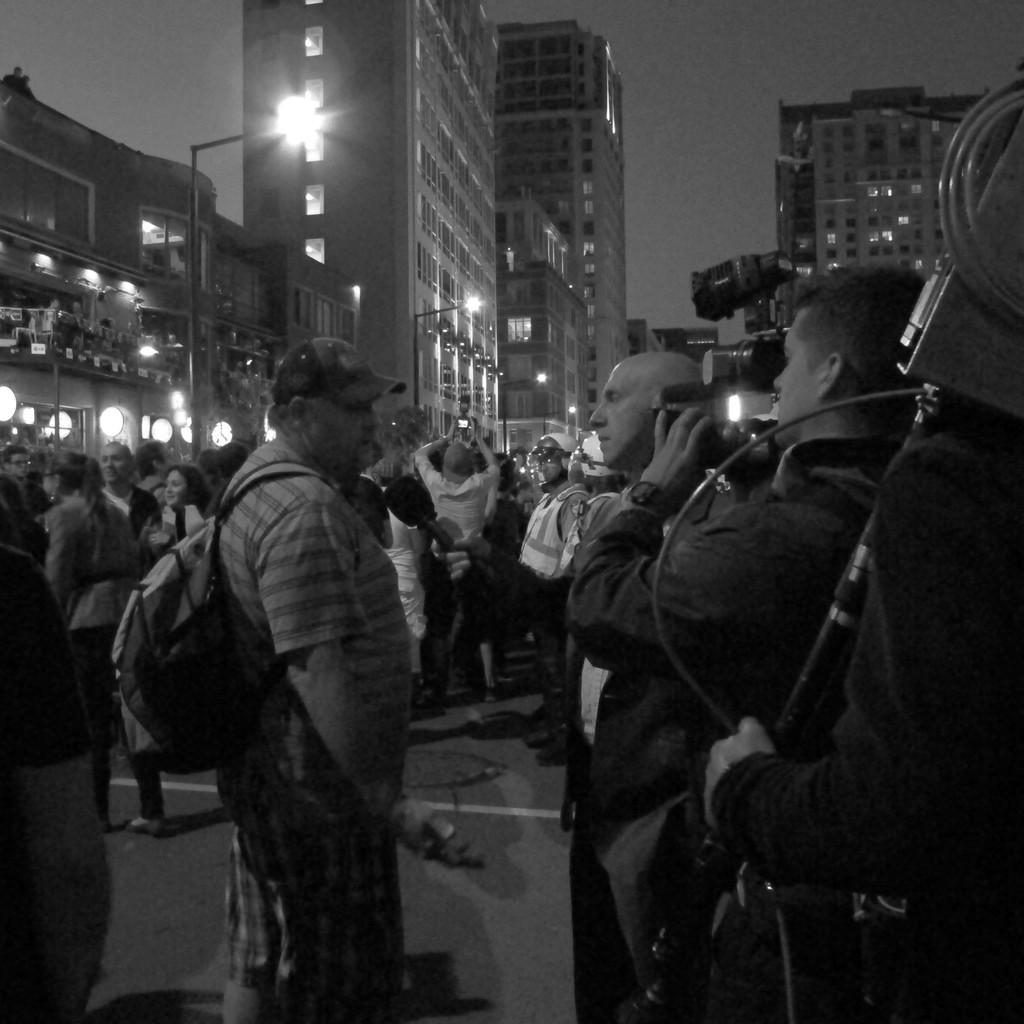Could you give a brief overview of what you see in this image? In this picture we can see a group of men and women standing on the road. In the front bottom side there a man standing and giving the interview to the media person carrying a camera in the hand. Behind there are some buildings and street lights. 